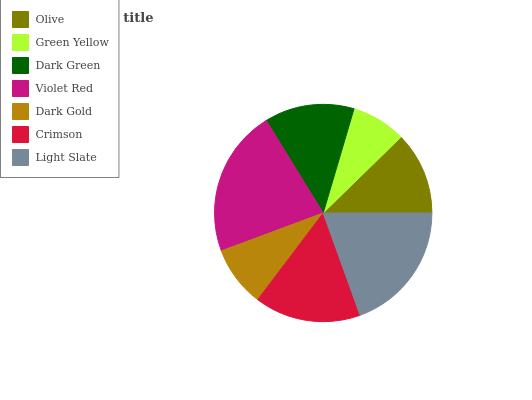Is Green Yellow the minimum?
Answer yes or no. Yes. Is Violet Red the maximum?
Answer yes or no. Yes. Is Dark Green the minimum?
Answer yes or no. No. Is Dark Green the maximum?
Answer yes or no. No. Is Dark Green greater than Green Yellow?
Answer yes or no. Yes. Is Green Yellow less than Dark Green?
Answer yes or no. Yes. Is Green Yellow greater than Dark Green?
Answer yes or no. No. Is Dark Green less than Green Yellow?
Answer yes or no. No. Is Dark Green the high median?
Answer yes or no. Yes. Is Dark Green the low median?
Answer yes or no. Yes. Is Violet Red the high median?
Answer yes or no. No. Is Olive the low median?
Answer yes or no. No. 